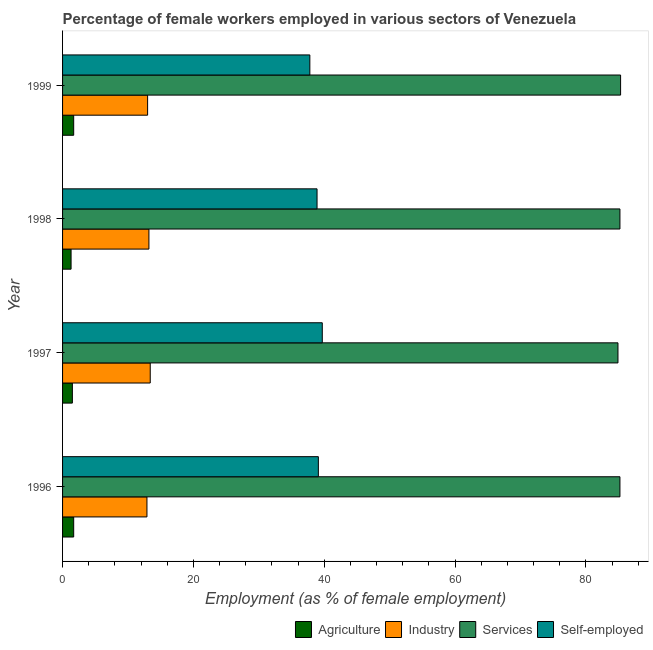How many different coloured bars are there?
Offer a terse response. 4. Are the number of bars per tick equal to the number of legend labels?
Your answer should be very brief. Yes. Are the number of bars on each tick of the Y-axis equal?
Ensure brevity in your answer.  Yes. How many bars are there on the 2nd tick from the bottom?
Ensure brevity in your answer.  4. What is the label of the 3rd group of bars from the top?
Give a very brief answer. 1997. In how many cases, is the number of bars for a given year not equal to the number of legend labels?
Give a very brief answer. 0. What is the percentage of female workers in agriculture in 1996?
Your response must be concise. 1.7. Across all years, what is the maximum percentage of female workers in industry?
Provide a succinct answer. 13.4. Across all years, what is the minimum percentage of female workers in industry?
Provide a short and direct response. 12.9. In which year was the percentage of self employed female workers maximum?
Offer a very short reply. 1997. What is the total percentage of female workers in industry in the graph?
Ensure brevity in your answer.  52.5. What is the difference between the percentage of self employed female workers in 1999 and the percentage of female workers in industry in 1998?
Provide a short and direct response. 24.6. What is the average percentage of female workers in agriculture per year?
Provide a succinct answer. 1.55. In the year 1996, what is the difference between the percentage of self employed female workers and percentage of female workers in services?
Your response must be concise. -46.1. What is the ratio of the percentage of female workers in services in 1997 to that in 1999?
Provide a succinct answer. 0.99. Is the percentage of female workers in services in 1996 less than that in 1999?
Make the answer very short. Yes. What is the difference between the highest and the lowest percentage of female workers in industry?
Keep it short and to the point. 0.5. What does the 1st bar from the top in 1996 represents?
Make the answer very short. Self-employed. What does the 4th bar from the bottom in 1998 represents?
Provide a short and direct response. Self-employed. Is it the case that in every year, the sum of the percentage of female workers in agriculture and percentage of female workers in industry is greater than the percentage of female workers in services?
Keep it short and to the point. No. Are the values on the major ticks of X-axis written in scientific E-notation?
Your answer should be compact. No. How many legend labels are there?
Provide a short and direct response. 4. What is the title of the graph?
Keep it short and to the point. Percentage of female workers employed in various sectors of Venezuela. Does "Secondary schools" appear as one of the legend labels in the graph?
Offer a terse response. No. What is the label or title of the X-axis?
Provide a succinct answer. Employment (as % of female employment). What is the Employment (as % of female employment) in Agriculture in 1996?
Offer a very short reply. 1.7. What is the Employment (as % of female employment) of Industry in 1996?
Offer a terse response. 12.9. What is the Employment (as % of female employment) in Services in 1996?
Ensure brevity in your answer.  85.2. What is the Employment (as % of female employment) in Self-employed in 1996?
Your response must be concise. 39.1. What is the Employment (as % of female employment) of Industry in 1997?
Keep it short and to the point. 13.4. What is the Employment (as % of female employment) of Services in 1997?
Your response must be concise. 84.9. What is the Employment (as % of female employment) in Self-employed in 1997?
Your response must be concise. 39.7. What is the Employment (as % of female employment) in Agriculture in 1998?
Ensure brevity in your answer.  1.3. What is the Employment (as % of female employment) in Industry in 1998?
Your answer should be very brief. 13.2. What is the Employment (as % of female employment) in Services in 1998?
Make the answer very short. 85.2. What is the Employment (as % of female employment) of Self-employed in 1998?
Give a very brief answer. 38.9. What is the Employment (as % of female employment) in Agriculture in 1999?
Your answer should be compact. 1.7. What is the Employment (as % of female employment) of Services in 1999?
Keep it short and to the point. 85.3. What is the Employment (as % of female employment) of Self-employed in 1999?
Ensure brevity in your answer.  37.8. Across all years, what is the maximum Employment (as % of female employment) of Agriculture?
Your answer should be very brief. 1.7. Across all years, what is the maximum Employment (as % of female employment) of Industry?
Provide a succinct answer. 13.4. Across all years, what is the maximum Employment (as % of female employment) of Services?
Make the answer very short. 85.3. Across all years, what is the maximum Employment (as % of female employment) of Self-employed?
Provide a short and direct response. 39.7. Across all years, what is the minimum Employment (as % of female employment) of Agriculture?
Your response must be concise. 1.3. Across all years, what is the minimum Employment (as % of female employment) in Industry?
Make the answer very short. 12.9. Across all years, what is the minimum Employment (as % of female employment) of Services?
Provide a short and direct response. 84.9. Across all years, what is the minimum Employment (as % of female employment) in Self-employed?
Provide a short and direct response. 37.8. What is the total Employment (as % of female employment) of Agriculture in the graph?
Your response must be concise. 6.2. What is the total Employment (as % of female employment) of Industry in the graph?
Your response must be concise. 52.5. What is the total Employment (as % of female employment) in Services in the graph?
Offer a very short reply. 340.6. What is the total Employment (as % of female employment) of Self-employed in the graph?
Ensure brevity in your answer.  155.5. What is the difference between the Employment (as % of female employment) of Industry in 1996 and that in 1998?
Give a very brief answer. -0.3. What is the difference between the Employment (as % of female employment) of Agriculture in 1996 and that in 1999?
Provide a short and direct response. 0. What is the difference between the Employment (as % of female employment) of Industry in 1996 and that in 1999?
Offer a very short reply. -0.1. What is the difference between the Employment (as % of female employment) in Services in 1996 and that in 1999?
Ensure brevity in your answer.  -0.1. What is the difference between the Employment (as % of female employment) of Industry in 1997 and that in 1998?
Give a very brief answer. 0.2. What is the difference between the Employment (as % of female employment) in Self-employed in 1997 and that in 1998?
Keep it short and to the point. 0.8. What is the difference between the Employment (as % of female employment) of Industry in 1997 and that in 1999?
Keep it short and to the point. 0.4. What is the difference between the Employment (as % of female employment) of Self-employed in 1997 and that in 1999?
Your answer should be very brief. 1.9. What is the difference between the Employment (as % of female employment) in Industry in 1998 and that in 1999?
Keep it short and to the point. 0.2. What is the difference between the Employment (as % of female employment) of Self-employed in 1998 and that in 1999?
Make the answer very short. 1.1. What is the difference between the Employment (as % of female employment) in Agriculture in 1996 and the Employment (as % of female employment) in Services in 1997?
Your response must be concise. -83.2. What is the difference between the Employment (as % of female employment) in Agriculture in 1996 and the Employment (as % of female employment) in Self-employed in 1997?
Keep it short and to the point. -38. What is the difference between the Employment (as % of female employment) of Industry in 1996 and the Employment (as % of female employment) of Services in 1997?
Your answer should be very brief. -72. What is the difference between the Employment (as % of female employment) in Industry in 1996 and the Employment (as % of female employment) in Self-employed in 1997?
Offer a very short reply. -26.8. What is the difference between the Employment (as % of female employment) of Services in 1996 and the Employment (as % of female employment) of Self-employed in 1997?
Your answer should be very brief. 45.5. What is the difference between the Employment (as % of female employment) in Agriculture in 1996 and the Employment (as % of female employment) in Industry in 1998?
Make the answer very short. -11.5. What is the difference between the Employment (as % of female employment) in Agriculture in 1996 and the Employment (as % of female employment) in Services in 1998?
Give a very brief answer. -83.5. What is the difference between the Employment (as % of female employment) in Agriculture in 1996 and the Employment (as % of female employment) in Self-employed in 1998?
Provide a short and direct response. -37.2. What is the difference between the Employment (as % of female employment) of Industry in 1996 and the Employment (as % of female employment) of Services in 1998?
Ensure brevity in your answer.  -72.3. What is the difference between the Employment (as % of female employment) of Services in 1996 and the Employment (as % of female employment) of Self-employed in 1998?
Provide a succinct answer. 46.3. What is the difference between the Employment (as % of female employment) in Agriculture in 1996 and the Employment (as % of female employment) in Services in 1999?
Give a very brief answer. -83.6. What is the difference between the Employment (as % of female employment) in Agriculture in 1996 and the Employment (as % of female employment) in Self-employed in 1999?
Keep it short and to the point. -36.1. What is the difference between the Employment (as % of female employment) of Industry in 1996 and the Employment (as % of female employment) of Services in 1999?
Offer a very short reply. -72.4. What is the difference between the Employment (as % of female employment) of Industry in 1996 and the Employment (as % of female employment) of Self-employed in 1999?
Offer a very short reply. -24.9. What is the difference between the Employment (as % of female employment) in Services in 1996 and the Employment (as % of female employment) in Self-employed in 1999?
Provide a short and direct response. 47.4. What is the difference between the Employment (as % of female employment) in Agriculture in 1997 and the Employment (as % of female employment) in Services in 1998?
Your answer should be very brief. -83.7. What is the difference between the Employment (as % of female employment) in Agriculture in 1997 and the Employment (as % of female employment) in Self-employed in 1998?
Ensure brevity in your answer.  -37.4. What is the difference between the Employment (as % of female employment) in Industry in 1997 and the Employment (as % of female employment) in Services in 1998?
Your answer should be very brief. -71.8. What is the difference between the Employment (as % of female employment) of Industry in 1997 and the Employment (as % of female employment) of Self-employed in 1998?
Your answer should be very brief. -25.5. What is the difference between the Employment (as % of female employment) of Services in 1997 and the Employment (as % of female employment) of Self-employed in 1998?
Your response must be concise. 46. What is the difference between the Employment (as % of female employment) of Agriculture in 1997 and the Employment (as % of female employment) of Services in 1999?
Make the answer very short. -83.8. What is the difference between the Employment (as % of female employment) of Agriculture in 1997 and the Employment (as % of female employment) of Self-employed in 1999?
Keep it short and to the point. -36.3. What is the difference between the Employment (as % of female employment) in Industry in 1997 and the Employment (as % of female employment) in Services in 1999?
Give a very brief answer. -71.9. What is the difference between the Employment (as % of female employment) of Industry in 1997 and the Employment (as % of female employment) of Self-employed in 1999?
Keep it short and to the point. -24.4. What is the difference between the Employment (as % of female employment) in Services in 1997 and the Employment (as % of female employment) in Self-employed in 1999?
Provide a succinct answer. 47.1. What is the difference between the Employment (as % of female employment) in Agriculture in 1998 and the Employment (as % of female employment) in Industry in 1999?
Make the answer very short. -11.7. What is the difference between the Employment (as % of female employment) of Agriculture in 1998 and the Employment (as % of female employment) of Services in 1999?
Ensure brevity in your answer.  -84. What is the difference between the Employment (as % of female employment) of Agriculture in 1998 and the Employment (as % of female employment) of Self-employed in 1999?
Your answer should be compact. -36.5. What is the difference between the Employment (as % of female employment) of Industry in 1998 and the Employment (as % of female employment) of Services in 1999?
Ensure brevity in your answer.  -72.1. What is the difference between the Employment (as % of female employment) in Industry in 1998 and the Employment (as % of female employment) in Self-employed in 1999?
Provide a short and direct response. -24.6. What is the difference between the Employment (as % of female employment) in Services in 1998 and the Employment (as % of female employment) in Self-employed in 1999?
Your response must be concise. 47.4. What is the average Employment (as % of female employment) of Agriculture per year?
Ensure brevity in your answer.  1.55. What is the average Employment (as % of female employment) in Industry per year?
Offer a terse response. 13.12. What is the average Employment (as % of female employment) in Services per year?
Your response must be concise. 85.15. What is the average Employment (as % of female employment) of Self-employed per year?
Provide a succinct answer. 38.88. In the year 1996, what is the difference between the Employment (as % of female employment) in Agriculture and Employment (as % of female employment) in Industry?
Offer a very short reply. -11.2. In the year 1996, what is the difference between the Employment (as % of female employment) in Agriculture and Employment (as % of female employment) in Services?
Your response must be concise. -83.5. In the year 1996, what is the difference between the Employment (as % of female employment) in Agriculture and Employment (as % of female employment) in Self-employed?
Offer a terse response. -37.4. In the year 1996, what is the difference between the Employment (as % of female employment) of Industry and Employment (as % of female employment) of Services?
Your answer should be very brief. -72.3. In the year 1996, what is the difference between the Employment (as % of female employment) in Industry and Employment (as % of female employment) in Self-employed?
Your answer should be compact. -26.2. In the year 1996, what is the difference between the Employment (as % of female employment) of Services and Employment (as % of female employment) of Self-employed?
Give a very brief answer. 46.1. In the year 1997, what is the difference between the Employment (as % of female employment) of Agriculture and Employment (as % of female employment) of Industry?
Your response must be concise. -11.9. In the year 1997, what is the difference between the Employment (as % of female employment) of Agriculture and Employment (as % of female employment) of Services?
Your answer should be very brief. -83.4. In the year 1997, what is the difference between the Employment (as % of female employment) in Agriculture and Employment (as % of female employment) in Self-employed?
Provide a succinct answer. -38.2. In the year 1997, what is the difference between the Employment (as % of female employment) in Industry and Employment (as % of female employment) in Services?
Provide a short and direct response. -71.5. In the year 1997, what is the difference between the Employment (as % of female employment) in Industry and Employment (as % of female employment) in Self-employed?
Keep it short and to the point. -26.3. In the year 1997, what is the difference between the Employment (as % of female employment) of Services and Employment (as % of female employment) of Self-employed?
Keep it short and to the point. 45.2. In the year 1998, what is the difference between the Employment (as % of female employment) of Agriculture and Employment (as % of female employment) of Industry?
Provide a succinct answer. -11.9. In the year 1998, what is the difference between the Employment (as % of female employment) of Agriculture and Employment (as % of female employment) of Services?
Your answer should be compact. -83.9. In the year 1998, what is the difference between the Employment (as % of female employment) of Agriculture and Employment (as % of female employment) of Self-employed?
Offer a terse response. -37.6. In the year 1998, what is the difference between the Employment (as % of female employment) in Industry and Employment (as % of female employment) in Services?
Keep it short and to the point. -72. In the year 1998, what is the difference between the Employment (as % of female employment) of Industry and Employment (as % of female employment) of Self-employed?
Provide a succinct answer. -25.7. In the year 1998, what is the difference between the Employment (as % of female employment) of Services and Employment (as % of female employment) of Self-employed?
Ensure brevity in your answer.  46.3. In the year 1999, what is the difference between the Employment (as % of female employment) in Agriculture and Employment (as % of female employment) in Services?
Ensure brevity in your answer.  -83.6. In the year 1999, what is the difference between the Employment (as % of female employment) of Agriculture and Employment (as % of female employment) of Self-employed?
Keep it short and to the point. -36.1. In the year 1999, what is the difference between the Employment (as % of female employment) in Industry and Employment (as % of female employment) in Services?
Ensure brevity in your answer.  -72.3. In the year 1999, what is the difference between the Employment (as % of female employment) of Industry and Employment (as % of female employment) of Self-employed?
Make the answer very short. -24.8. In the year 1999, what is the difference between the Employment (as % of female employment) in Services and Employment (as % of female employment) in Self-employed?
Your response must be concise. 47.5. What is the ratio of the Employment (as % of female employment) of Agriculture in 1996 to that in 1997?
Provide a short and direct response. 1.13. What is the ratio of the Employment (as % of female employment) in Industry in 1996 to that in 1997?
Your response must be concise. 0.96. What is the ratio of the Employment (as % of female employment) in Services in 1996 to that in 1997?
Give a very brief answer. 1. What is the ratio of the Employment (as % of female employment) in Self-employed in 1996 to that in 1997?
Give a very brief answer. 0.98. What is the ratio of the Employment (as % of female employment) of Agriculture in 1996 to that in 1998?
Offer a terse response. 1.31. What is the ratio of the Employment (as % of female employment) in Industry in 1996 to that in 1998?
Offer a terse response. 0.98. What is the ratio of the Employment (as % of female employment) in Self-employed in 1996 to that in 1998?
Your answer should be very brief. 1.01. What is the ratio of the Employment (as % of female employment) of Agriculture in 1996 to that in 1999?
Your answer should be compact. 1. What is the ratio of the Employment (as % of female employment) in Services in 1996 to that in 1999?
Offer a very short reply. 1. What is the ratio of the Employment (as % of female employment) of Self-employed in 1996 to that in 1999?
Give a very brief answer. 1.03. What is the ratio of the Employment (as % of female employment) in Agriculture in 1997 to that in 1998?
Keep it short and to the point. 1.15. What is the ratio of the Employment (as % of female employment) of Industry in 1997 to that in 1998?
Offer a terse response. 1.02. What is the ratio of the Employment (as % of female employment) in Services in 1997 to that in 1998?
Your answer should be compact. 1. What is the ratio of the Employment (as % of female employment) in Self-employed in 1997 to that in 1998?
Your response must be concise. 1.02. What is the ratio of the Employment (as % of female employment) of Agriculture in 1997 to that in 1999?
Provide a short and direct response. 0.88. What is the ratio of the Employment (as % of female employment) of Industry in 1997 to that in 1999?
Provide a succinct answer. 1.03. What is the ratio of the Employment (as % of female employment) in Services in 1997 to that in 1999?
Your answer should be compact. 1. What is the ratio of the Employment (as % of female employment) in Self-employed in 1997 to that in 1999?
Your answer should be compact. 1.05. What is the ratio of the Employment (as % of female employment) of Agriculture in 1998 to that in 1999?
Your answer should be compact. 0.76. What is the ratio of the Employment (as % of female employment) of Industry in 1998 to that in 1999?
Give a very brief answer. 1.02. What is the ratio of the Employment (as % of female employment) in Self-employed in 1998 to that in 1999?
Your answer should be compact. 1.03. What is the difference between the highest and the second highest Employment (as % of female employment) of Industry?
Ensure brevity in your answer.  0.2. What is the difference between the highest and the second highest Employment (as % of female employment) of Self-employed?
Ensure brevity in your answer.  0.6. What is the difference between the highest and the lowest Employment (as % of female employment) of Industry?
Your response must be concise. 0.5. What is the difference between the highest and the lowest Employment (as % of female employment) in Self-employed?
Give a very brief answer. 1.9. 